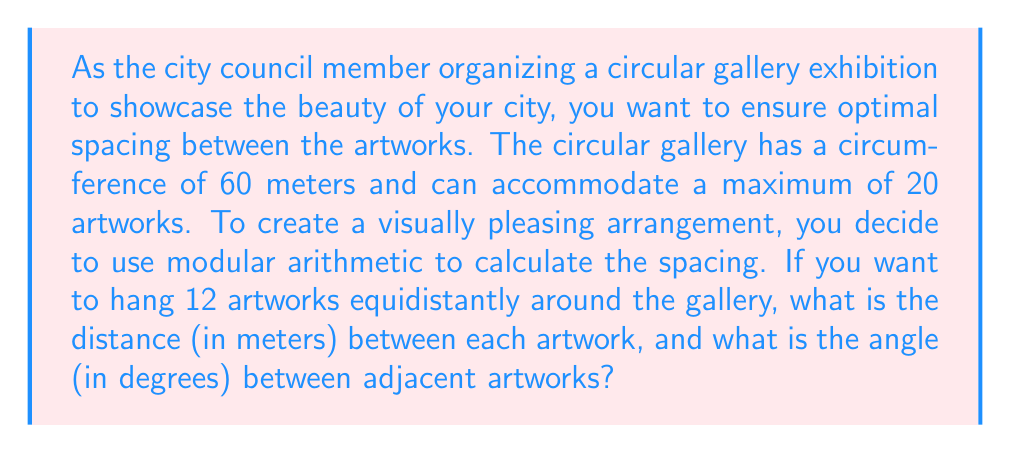Give your solution to this math problem. To solve this problem, we'll use modular arithmetic and some basic geometry concepts:

1. Calculate the spacing between artworks:
   - The circumference of the gallery is 60 meters
   - We need to divide this evenly among 12 artworks
   - Spacing = $60 \div 12 = 5$ meters

2. Calculate the angle between adjacent artworks:
   - A full circle has 360°
   - We need to divide this evenly among 12 artworks
   - Angle = $360° \div 12 = 30°$

3. Verify using modular arithmetic:
   - Let's represent each artwork's position as an integer from 0 to 11
   - In modular arithmetic, we work with the remainder after division by 12
   - The position of each artwork can be represented as $5k \bmod 60$ for $k = 0, 1, 2, ..., 11$
   - Let's calculate the positions:
     $$\begin{align*}
     k = 0: & \; 5 \cdot 0 \bmod 60 = 0 \\
     k = 1: & \; 5 \cdot 1 \bmod 60 = 5 \\
     k = 2: & \; 5 \cdot 2 \bmod 60 = 10 \\
     & \; \vdots \\
     k = 11: & \; 5 \cdot 11 \bmod 60 = 55
     \end{align*}$$

   This confirms that the artworks are evenly spaced around the gallery.

4. Angle calculation using modular arithmetic:
   - Each position increment of 5 meters corresponds to a 30° angle
   - In modular arithmetic: $30k \bmod 360$ for $k = 0, 1, 2, ..., 11$
   - This gives us angles: 0°, 30°, 60°, ..., 330°

Thus, using modular arithmetic, we've confirmed that the spacing of 5 meters and angle of 30° between adjacent artworks creates an equidistant arrangement in the circular gallery.
Answer: The distance between each artwork is 5 meters, and the angle between adjacent artworks is 30°. 